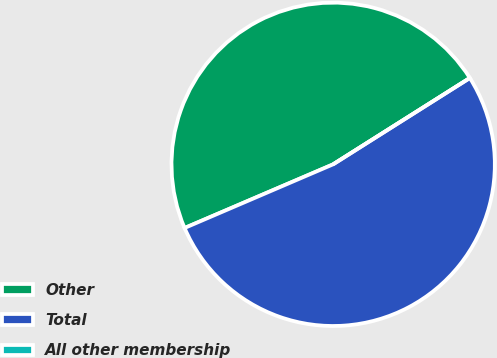Convert chart. <chart><loc_0><loc_0><loc_500><loc_500><pie_chart><fcel>Other<fcel>Total<fcel>All other membership<nl><fcel>47.48%<fcel>52.52%<fcel>0.0%<nl></chart> 